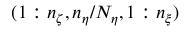<formula> <loc_0><loc_0><loc_500><loc_500>( 1 \colon n _ { \zeta } , n _ { \eta } / N _ { \eta } , 1 \colon n _ { \xi } )</formula> 